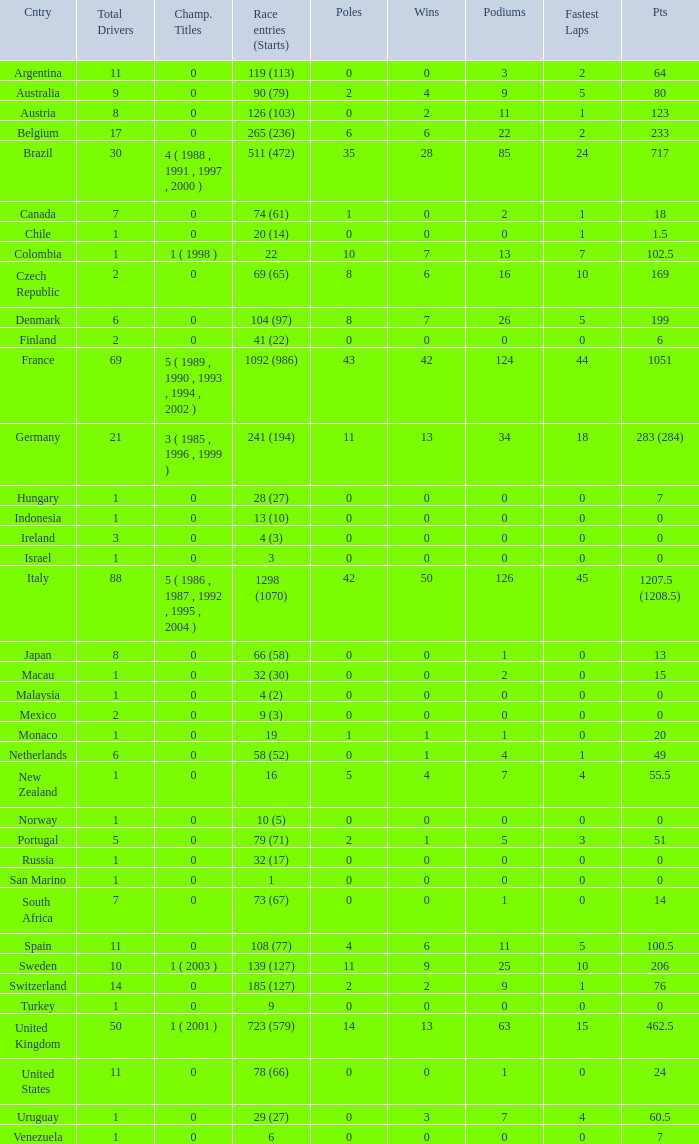How many titles for the nation with less than 3 fastest laps and 22 podiums? 0.0. 